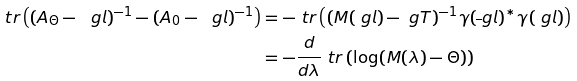<formula> <loc_0><loc_0><loc_500><loc_500>\ t r \left ( ( A _ { \Theta } - \ g l ) ^ { - 1 } - ( A _ { 0 } - \ g l ) ^ { - 1 } \right ) & = - \ t r \left ( ( M ( \ g l ) - \ g T ) ^ { - 1 } \gamma ( \overline { \ } g l ) ^ { * } \gamma ( \ g l ) \right ) \\ & = - \frac { d } { d \lambda } \ t r \left ( \log ( M ( \lambda ) - \Theta ) \right )</formula> 